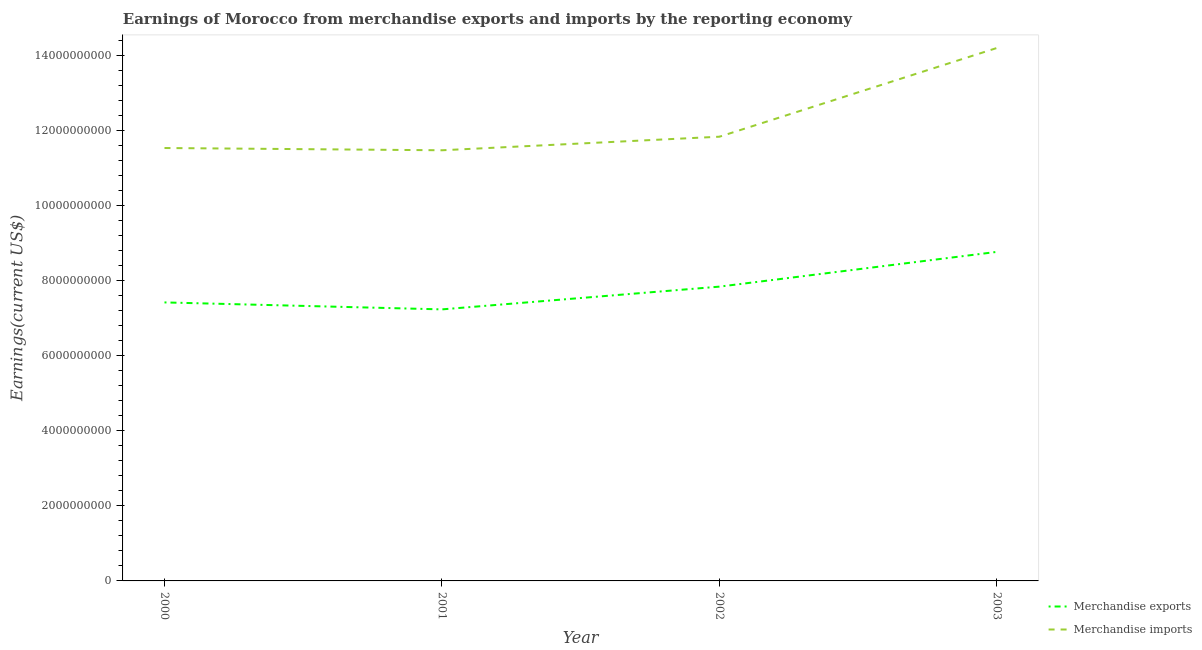What is the earnings from merchandise imports in 2001?
Keep it short and to the point. 1.15e+1. Across all years, what is the maximum earnings from merchandise imports?
Offer a very short reply. 1.42e+1. Across all years, what is the minimum earnings from merchandise imports?
Offer a very short reply. 1.15e+1. What is the total earnings from merchandise exports in the graph?
Provide a short and direct response. 3.13e+1. What is the difference between the earnings from merchandise imports in 2002 and that in 2003?
Give a very brief answer. -2.36e+09. What is the difference between the earnings from merchandise imports in 2003 and the earnings from merchandise exports in 2000?
Offer a very short reply. 6.78e+09. What is the average earnings from merchandise imports per year?
Your answer should be very brief. 1.23e+1. In the year 2002, what is the difference between the earnings from merchandise exports and earnings from merchandise imports?
Your answer should be compact. -3.99e+09. In how many years, is the earnings from merchandise imports greater than 6800000000 US$?
Your answer should be compact. 4. What is the ratio of the earnings from merchandise exports in 2000 to that in 2002?
Your response must be concise. 0.95. Is the earnings from merchandise imports in 2000 less than that in 2001?
Provide a succinct answer. No. What is the difference between the highest and the second highest earnings from merchandise exports?
Provide a succinct answer. 9.26e+08. What is the difference between the highest and the lowest earnings from merchandise exports?
Your answer should be very brief. 1.53e+09. In how many years, is the earnings from merchandise imports greater than the average earnings from merchandise imports taken over all years?
Keep it short and to the point. 1. Is the earnings from merchandise imports strictly less than the earnings from merchandise exports over the years?
Keep it short and to the point. No. Are the values on the major ticks of Y-axis written in scientific E-notation?
Make the answer very short. No. Does the graph contain any zero values?
Give a very brief answer. No. Where does the legend appear in the graph?
Provide a succinct answer. Bottom right. What is the title of the graph?
Offer a very short reply. Earnings of Morocco from merchandise exports and imports by the reporting economy. Does "Personal remittances" appear as one of the legend labels in the graph?
Ensure brevity in your answer.  No. What is the label or title of the X-axis?
Your response must be concise. Year. What is the label or title of the Y-axis?
Keep it short and to the point. Earnings(current US$). What is the Earnings(current US$) in Merchandise exports in 2000?
Make the answer very short. 7.42e+09. What is the Earnings(current US$) of Merchandise imports in 2000?
Keep it short and to the point. 1.15e+1. What is the Earnings(current US$) of Merchandise exports in 2001?
Provide a succinct answer. 7.23e+09. What is the Earnings(current US$) of Merchandise imports in 2001?
Your answer should be very brief. 1.15e+1. What is the Earnings(current US$) in Merchandise exports in 2002?
Offer a very short reply. 7.84e+09. What is the Earnings(current US$) in Merchandise imports in 2002?
Make the answer very short. 1.18e+1. What is the Earnings(current US$) of Merchandise exports in 2003?
Your answer should be very brief. 8.77e+09. What is the Earnings(current US$) of Merchandise imports in 2003?
Your answer should be compact. 1.42e+1. Across all years, what is the maximum Earnings(current US$) in Merchandise exports?
Your response must be concise. 8.77e+09. Across all years, what is the maximum Earnings(current US$) in Merchandise imports?
Your answer should be compact. 1.42e+1. Across all years, what is the minimum Earnings(current US$) in Merchandise exports?
Offer a terse response. 7.23e+09. Across all years, what is the minimum Earnings(current US$) of Merchandise imports?
Give a very brief answer. 1.15e+1. What is the total Earnings(current US$) of Merchandise exports in the graph?
Offer a very short reply. 3.13e+1. What is the total Earnings(current US$) of Merchandise imports in the graph?
Provide a short and direct response. 4.90e+1. What is the difference between the Earnings(current US$) of Merchandise exports in 2000 and that in 2001?
Make the answer very short. 1.86e+08. What is the difference between the Earnings(current US$) of Merchandise imports in 2000 and that in 2001?
Your answer should be very brief. 6.01e+07. What is the difference between the Earnings(current US$) of Merchandise exports in 2000 and that in 2002?
Provide a succinct answer. -4.20e+08. What is the difference between the Earnings(current US$) of Merchandise imports in 2000 and that in 2002?
Offer a very short reply. -3.01e+08. What is the difference between the Earnings(current US$) in Merchandise exports in 2000 and that in 2003?
Provide a short and direct response. -1.35e+09. What is the difference between the Earnings(current US$) of Merchandise imports in 2000 and that in 2003?
Your answer should be compact. -2.67e+09. What is the difference between the Earnings(current US$) in Merchandise exports in 2001 and that in 2002?
Provide a succinct answer. -6.06e+08. What is the difference between the Earnings(current US$) in Merchandise imports in 2001 and that in 2002?
Keep it short and to the point. -3.62e+08. What is the difference between the Earnings(current US$) of Merchandise exports in 2001 and that in 2003?
Provide a short and direct response. -1.53e+09. What is the difference between the Earnings(current US$) of Merchandise imports in 2001 and that in 2003?
Provide a succinct answer. -2.73e+09. What is the difference between the Earnings(current US$) in Merchandise exports in 2002 and that in 2003?
Offer a very short reply. -9.26e+08. What is the difference between the Earnings(current US$) in Merchandise imports in 2002 and that in 2003?
Provide a short and direct response. -2.36e+09. What is the difference between the Earnings(current US$) in Merchandise exports in 2000 and the Earnings(current US$) in Merchandise imports in 2001?
Your response must be concise. -4.05e+09. What is the difference between the Earnings(current US$) in Merchandise exports in 2000 and the Earnings(current US$) in Merchandise imports in 2002?
Offer a very short reply. -4.41e+09. What is the difference between the Earnings(current US$) of Merchandise exports in 2000 and the Earnings(current US$) of Merchandise imports in 2003?
Ensure brevity in your answer.  -6.78e+09. What is the difference between the Earnings(current US$) in Merchandise exports in 2001 and the Earnings(current US$) in Merchandise imports in 2002?
Your answer should be very brief. -4.60e+09. What is the difference between the Earnings(current US$) of Merchandise exports in 2001 and the Earnings(current US$) of Merchandise imports in 2003?
Give a very brief answer. -6.96e+09. What is the difference between the Earnings(current US$) in Merchandise exports in 2002 and the Earnings(current US$) in Merchandise imports in 2003?
Offer a very short reply. -6.36e+09. What is the average Earnings(current US$) of Merchandise exports per year?
Your answer should be very brief. 7.81e+09. What is the average Earnings(current US$) in Merchandise imports per year?
Give a very brief answer. 1.23e+1. In the year 2000, what is the difference between the Earnings(current US$) of Merchandise exports and Earnings(current US$) of Merchandise imports?
Make the answer very short. -4.11e+09. In the year 2001, what is the difference between the Earnings(current US$) of Merchandise exports and Earnings(current US$) of Merchandise imports?
Provide a short and direct response. -4.24e+09. In the year 2002, what is the difference between the Earnings(current US$) in Merchandise exports and Earnings(current US$) in Merchandise imports?
Offer a very short reply. -3.99e+09. In the year 2003, what is the difference between the Earnings(current US$) of Merchandise exports and Earnings(current US$) of Merchandise imports?
Offer a terse response. -5.43e+09. What is the ratio of the Earnings(current US$) in Merchandise exports in 2000 to that in 2001?
Keep it short and to the point. 1.03. What is the ratio of the Earnings(current US$) in Merchandise exports in 2000 to that in 2002?
Offer a very short reply. 0.95. What is the ratio of the Earnings(current US$) in Merchandise imports in 2000 to that in 2002?
Your answer should be compact. 0.97. What is the ratio of the Earnings(current US$) in Merchandise exports in 2000 to that in 2003?
Provide a succinct answer. 0.85. What is the ratio of the Earnings(current US$) of Merchandise imports in 2000 to that in 2003?
Provide a succinct answer. 0.81. What is the ratio of the Earnings(current US$) of Merchandise exports in 2001 to that in 2002?
Provide a succinct answer. 0.92. What is the ratio of the Earnings(current US$) of Merchandise imports in 2001 to that in 2002?
Offer a very short reply. 0.97. What is the ratio of the Earnings(current US$) of Merchandise exports in 2001 to that in 2003?
Your response must be concise. 0.83. What is the ratio of the Earnings(current US$) of Merchandise imports in 2001 to that in 2003?
Provide a succinct answer. 0.81. What is the ratio of the Earnings(current US$) in Merchandise exports in 2002 to that in 2003?
Make the answer very short. 0.89. What is the ratio of the Earnings(current US$) of Merchandise imports in 2002 to that in 2003?
Provide a short and direct response. 0.83. What is the difference between the highest and the second highest Earnings(current US$) of Merchandise exports?
Provide a short and direct response. 9.26e+08. What is the difference between the highest and the second highest Earnings(current US$) of Merchandise imports?
Provide a short and direct response. 2.36e+09. What is the difference between the highest and the lowest Earnings(current US$) of Merchandise exports?
Your answer should be very brief. 1.53e+09. What is the difference between the highest and the lowest Earnings(current US$) in Merchandise imports?
Your response must be concise. 2.73e+09. 